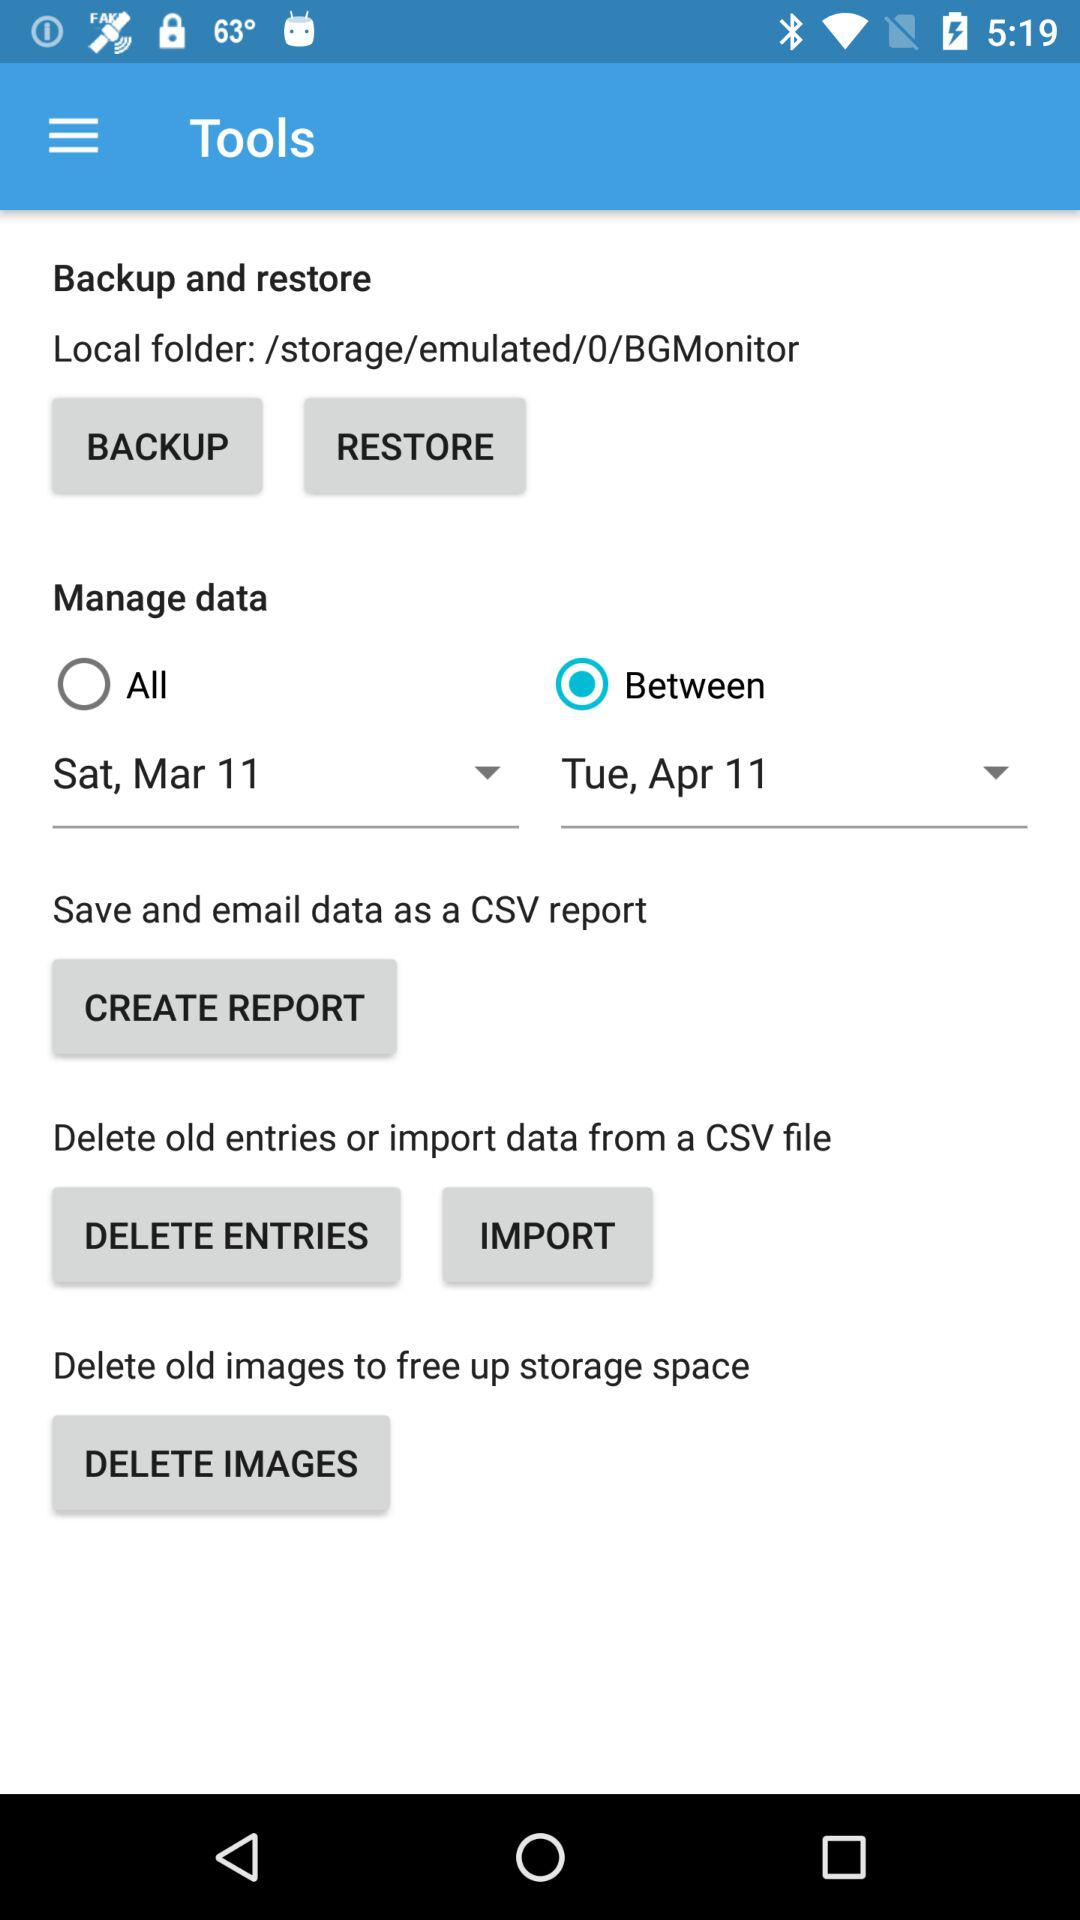How many images can be deleted to free up storage?
When the provided information is insufficient, respond with <no answer>. <no answer> 